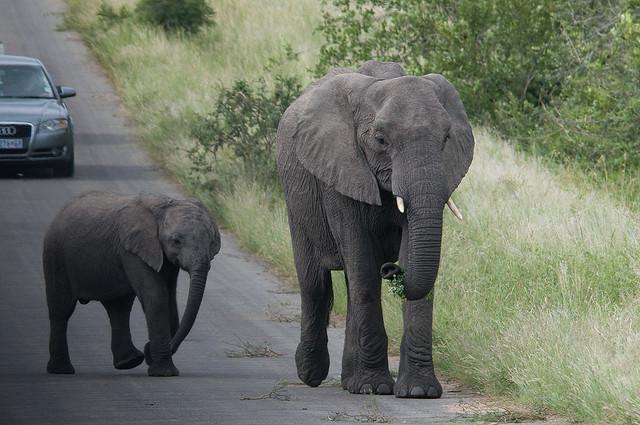What movie character fits in with these animals?
Indicate the correct choice and explain in the format: 'Answer: answer
Rationale: rationale.'
Options: Benji, mr ed, garfield, dumbo. Answer: dumbo.
Rationale: The animals are elephants. What make of car is behind the elephants?
Indicate the correct choice and explain in the format: 'Answer: answer
Rationale: rationale.'
Options: Mercedes benz, audi, chevrolet, ford. Answer: audi.
Rationale: There is a logo on the front of the car. it has four rings. 